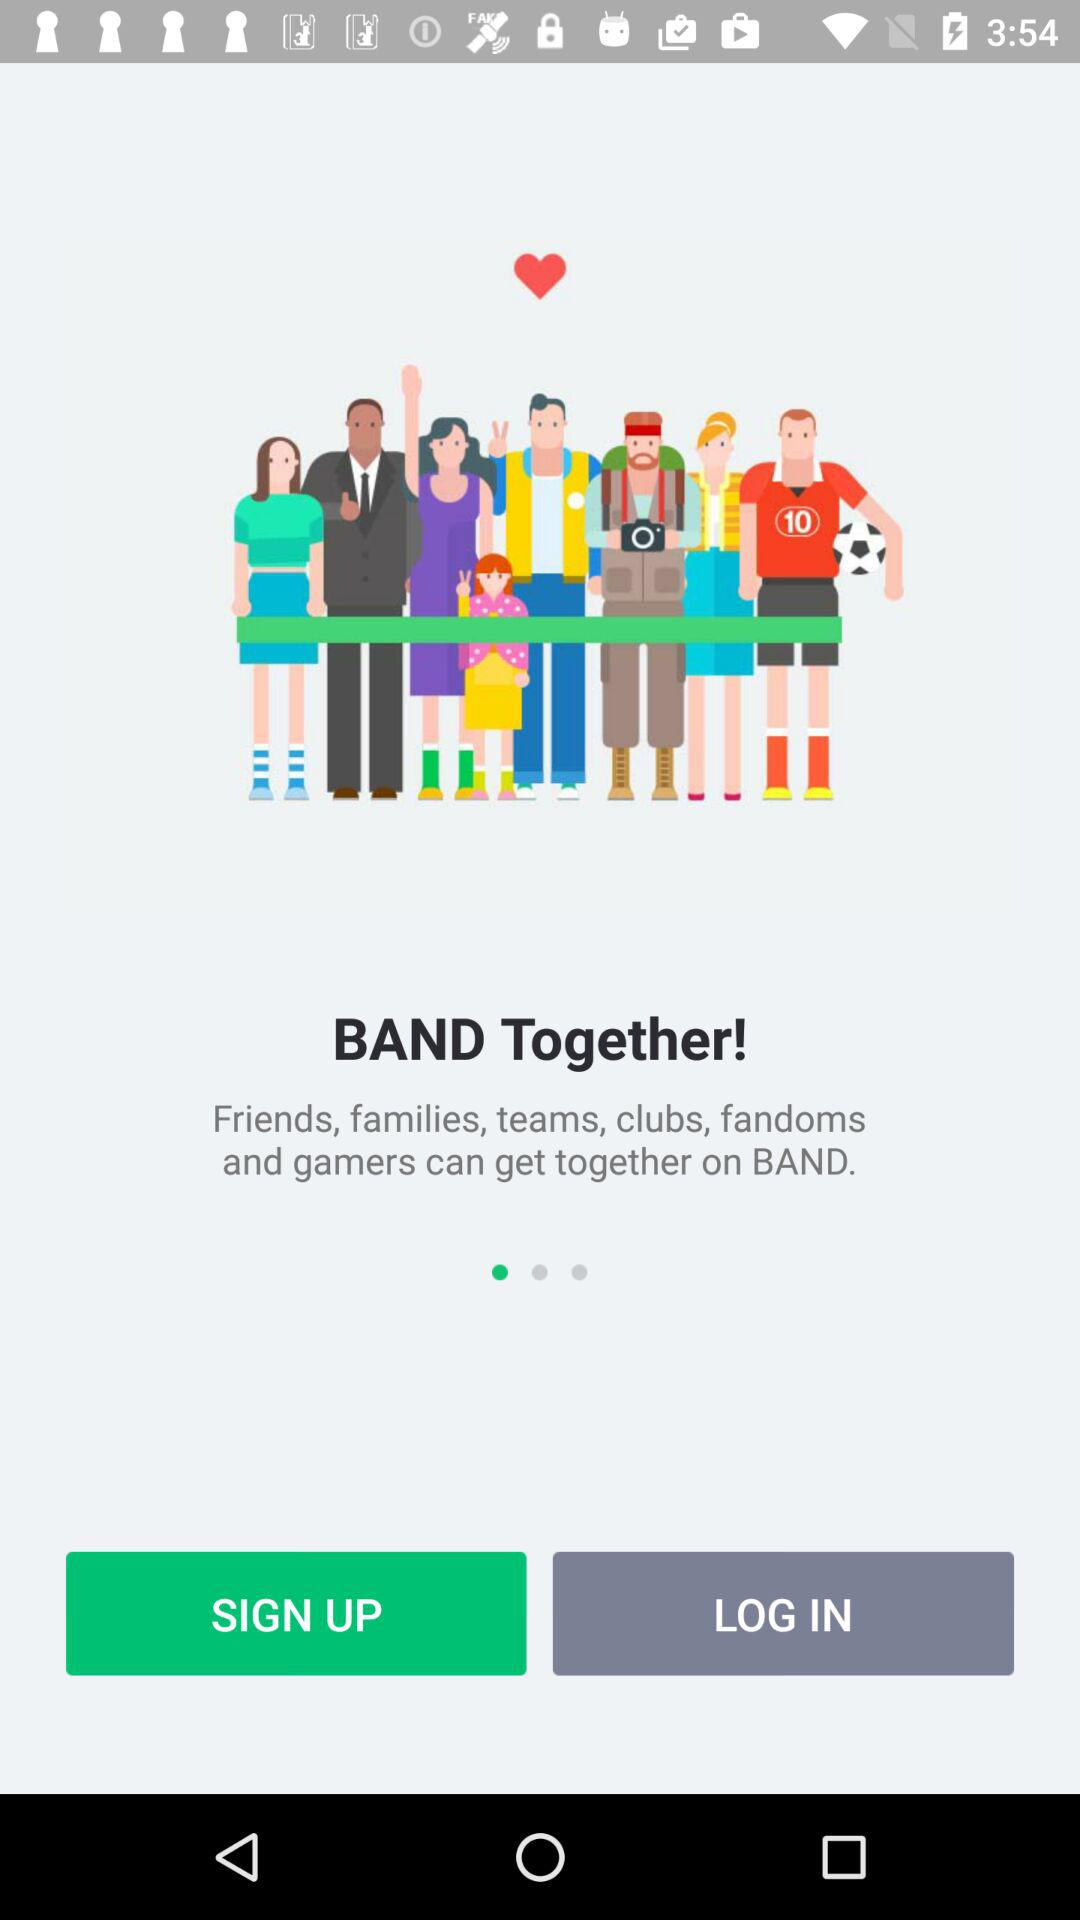What is the name of the application? The name of the application is "BAND". 